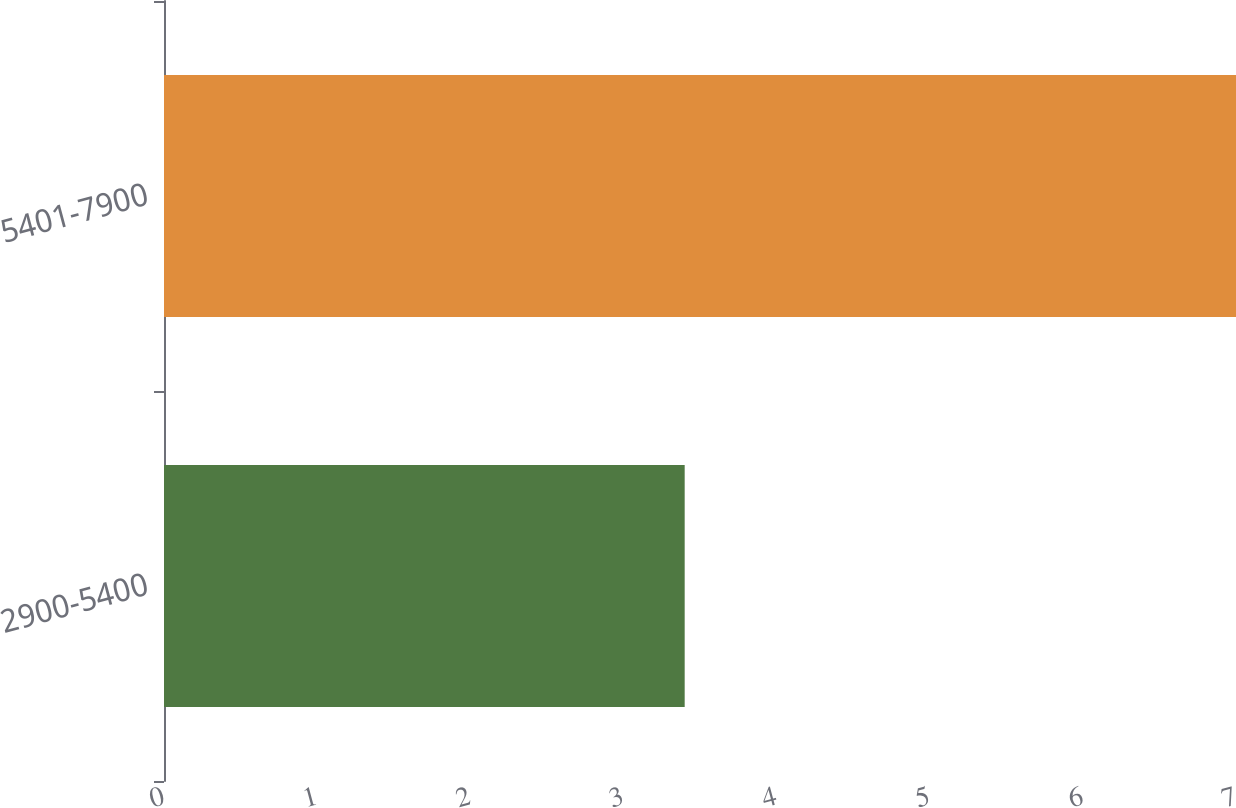<chart> <loc_0><loc_0><loc_500><loc_500><bar_chart><fcel>2900-5400<fcel>5401-7900<nl><fcel>3.4<fcel>7<nl></chart> 